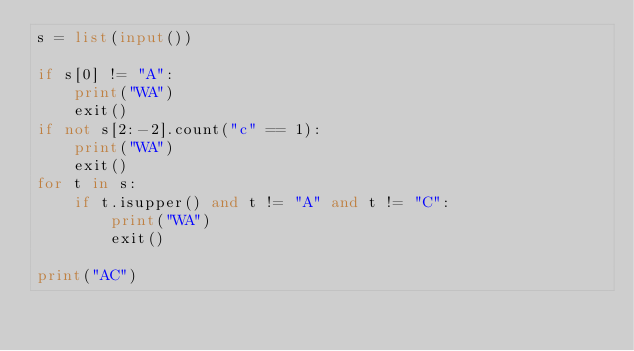<code> <loc_0><loc_0><loc_500><loc_500><_Python_>s = list(input())

if s[0] != "A":
    print("WA")
    exit()
if not s[2:-2].count("c" == 1):
    print("WA")
    exit()
for t in s:
    if t.isupper() and t != "A" and t != "C":
        print("WA")
        exit()

print("AC")
</code> 